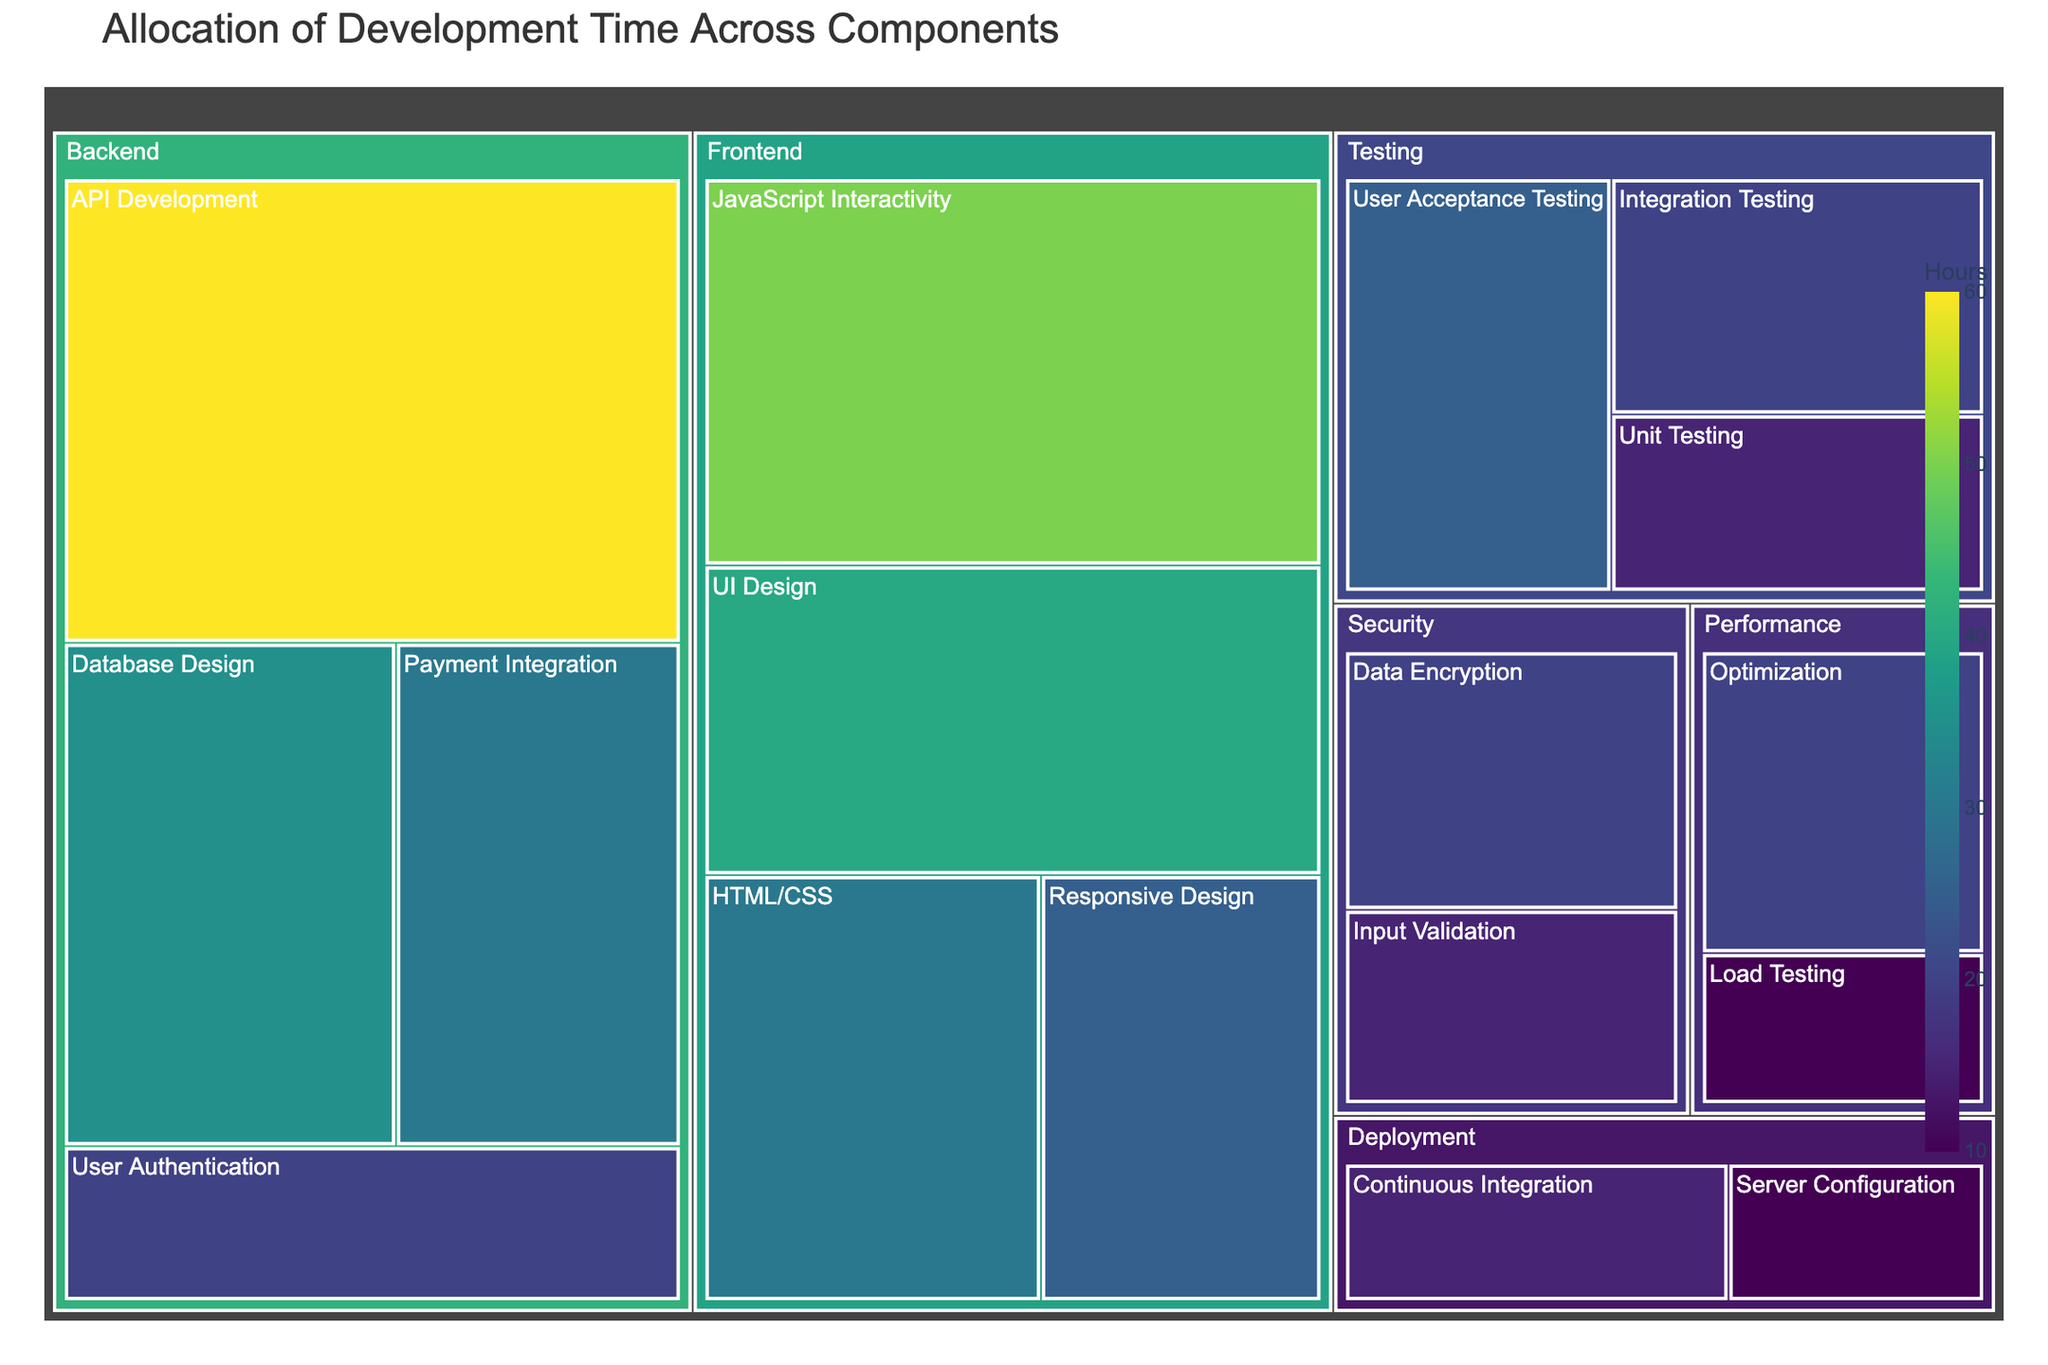What is the title of the treemap? The title is shown at the top of the treemap. It helps to explain what the figure is about.
Answer: Allocation of Development Time Across Components Which subcomponent in the Frontend category has the highest allocated hours? By looking at the treemap under the Frontend category (which is on the left side of the treemap), identify the subcomponent with the largest area and the corresponding number of hours.
Answer: JavaScript Interactivity How many hours are allocated to API Development in the Backend component? Find the Backend component and locate the API Development subcomponent. The figure provides the exact hours in the hover data.
Answer: 60 What is the total number of hours allocated to the Testing component? Sum the hours of all subcomponents under the Testing category. This would include Unit Testing, Integration Testing, and User Acceptance Testing.
Answer: 60 Which component has the smallest allocated time, and how many hours is it? Look for the smallest tile on the treemap to find the component and then refer to the hover data or value shown.
Answer: Deployment, 25 hours Compare the hours allocated to Database Design and Payment Integration. Which one has more hours and by how many? Identify the areas corresponding to Database Design and Payment Integration in the Backend component, check their respective hours, and calculate the difference.
Answer: Database Design by 5 hours What is the average number of hours allocated to subcomponents in the Security component? Sum the hours of all subcomponents under the Security category (Data Encryption and Input Validation) and divide by the number of subcomponents.
Answer: 17.5 Which component has the highest total allocated hours? Look at the summary or total value for each component (Frontend, Backend, Testing, Deployment, Security, Performance) and identify the one with the highest value.
Answer: Backend How much more time is allocated to JavaScript Interactivity compared to HTML/CSS? Locate both subcomponents under Frontend, find the number of hours allocated to each, and subtract the smaller value from the larger one.
Answer: 20 What are the total number of hours allocated to Performance-related tasks? Sum the hours of all subcomponents under the Performance category (Load Testing and Optimization).
Answer: 30 